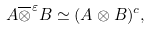Convert formula to latex. <formula><loc_0><loc_0><loc_500><loc_500>A \overline { \otimes } ^ { \varepsilon } B \simeq ( A \otimes B ) ^ { c } ,</formula> 